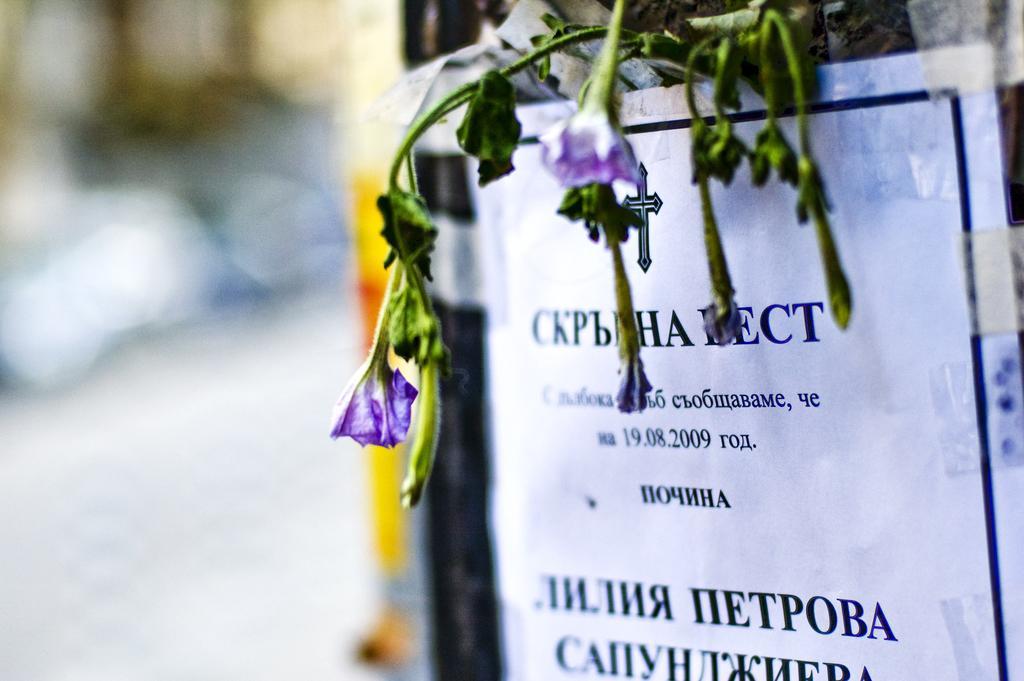In one or two sentences, can you explain what this image depicts? In the image there is a paper with some printed text and flowers above it on a wall and the background is blurry. 